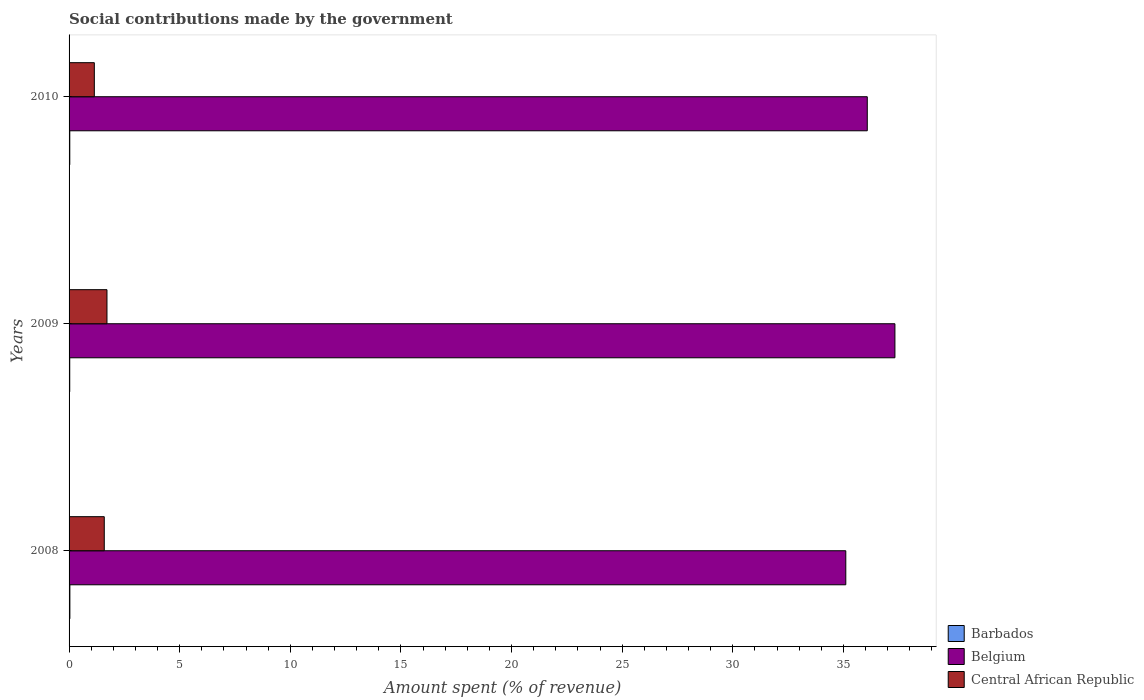How many different coloured bars are there?
Your answer should be very brief. 3. How many groups of bars are there?
Keep it short and to the point. 3. Are the number of bars per tick equal to the number of legend labels?
Your answer should be compact. Yes. Are the number of bars on each tick of the Y-axis equal?
Ensure brevity in your answer.  Yes. How many bars are there on the 1st tick from the bottom?
Offer a very short reply. 3. What is the amount spent (in %) on social contributions in Central African Republic in 2010?
Provide a short and direct response. 1.14. Across all years, what is the maximum amount spent (in %) on social contributions in Barbados?
Make the answer very short. 0.04. Across all years, what is the minimum amount spent (in %) on social contributions in Belgium?
Make the answer very short. 35.11. What is the total amount spent (in %) on social contributions in Barbados in the graph?
Give a very brief answer. 0.1. What is the difference between the amount spent (in %) on social contributions in Central African Republic in 2008 and that in 2009?
Make the answer very short. -0.12. What is the difference between the amount spent (in %) on social contributions in Barbados in 2010 and the amount spent (in %) on social contributions in Belgium in 2009?
Make the answer very short. -37.3. What is the average amount spent (in %) on social contributions in Barbados per year?
Offer a terse response. 0.03. In the year 2009, what is the difference between the amount spent (in %) on social contributions in Belgium and amount spent (in %) on social contributions in Central African Republic?
Your answer should be very brief. 35.62. In how many years, is the amount spent (in %) on social contributions in Barbados greater than 28 %?
Offer a very short reply. 0. What is the ratio of the amount spent (in %) on social contributions in Central African Republic in 2009 to that in 2010?
Provide a succinct answer. 1.5. Is the amount spent (in %) on social contributions in Barbados in 2009 less than that in 2010?
Keep it short and to the point. Yes. What is the difference between the highest and the second highest amount spent (in %) on social contributions in Central African Republic?
Ensure brevity in your answer.  0.12. What is the difference between the highest and the lowest amount spent (in %) on social contributions in Central African Republic?
Your response must be concise. 0.57. In how many years, is the amount spent (in %) on social contributions in Barbados greater than the average amount spent (in %) on social contributions in Barbados taken over all years?
Your answer should be very brief. 1. What does the 3rd bar from the top in 2010 represents?
Provide a short and direct response. Barbados. What does the 3rd bar from the bottom in 2008 represents?
Give a very brief answer. Central African Republic. Are all the bars in the graph horizontal?
Your response must be concise. Yes. Are the values on the major ticks of X-axis written in scientific E-notation?
Offer a terse response. No. Does the graph contain any zero values?
Offer a very short reply. No. Does the graph contain grids?
Provide a short and direct response. No. Where does the legend appear in the graph?
Keep it short and to the point. Bottom right. What is the title of the graph?
Your response must be concise. Social contributions made by the government. Does "Hungary" appear as one of the legend labels in the graph?
Ensure brevity in your answer.  No. What is the label or title of the X-axis?
Give a very brief answer. Amount spent (% of revenue). What is the Amount spent (% of revenue) in Barbados in 2008?
Make the answer very short. 0.04. What is the Amount spent (% of revenue) in Belgium in 2008?
Your answer should be compact. 35.11. What is the Amount spent (% of revenue) in Central African Republic in 2008?
Give a very brief answer. 1.59. What is the Amount spent (% of revenue) of Barbados in 2009?
Your response must be concise. 0.03. What is the Amount spent (% of revenue) of Belgium in 2009?
Keep it short and to the point. 37.33. What is the Amount spent (% of revenue) in Central African Republic in 2009?
Your answer should be compact. 1.71. What is the Amount spent (% of revenue) in Barbados in 2010?
Offer a terse response. 0.03. What is the Amount spent (% of revenue) of Belgium in 2010?
Offer a terse response. 36.08. What is the Amount spent (% of revenue) in Central African Republic in 2010?
Offer a very short reply. 1.14. Across all years, what is the maximum Amount spent (% of revenue) in Barbados?
Provide a short and direct response. 0.04. Across all years, what is the maximum Amount spent (% of revenue) of Belgium?
Offer a very short reply. 37.33. Across all years, what is the maximum Amount spent (% of revenue) of Central African Republic?
Your response must be concise. 1.71. Across all years, what is the minimum Amount spent (% of revenue) of Barbados?
Offer a terse response. 0.03. Across all years, what is the minimum Amount spent (% of revenue) in Belgium?
Your response must be concise. 35.11. Across all years, what is the minimum Amount spent (% of revenue) of Central African Republic?
Make the answer very short. 1.14. What is the total Amount spent (% of revenue) in Barbados in the graph?
Provide a short and direct response. 0.1. What is the total Amount spent (% of revenue) of Belgium in the graph?
Offer a very short reply. 108.52. What is the total Amount spent (% of revenue) in Central African Republic in the graph?
Your response must be concise. 4.45. What is the difference between the Amount spent (% of revenue) in Barbados in 2008 and that in 2009?
Offer a very short reply. 0.01. What is the difference between the Amount spent (% of revenue) of Belgium in 2008 and that in 2009?
Provide a succinct answer. -2.22. What is the difference between the Amount spent (% of revenue) of Central African Republic in 2008 and that in 2009?
Your response must be concise. -0.12. What is the difference between the Amount spent (% of revenue) of Barbados in 2008 and that in 2010?
Provide a short and direct response. 0. What is the difference between the Amount spent (% of revenue) in Belgium in 2008 and that in 2010?
Provide a short and direct response. -0.97. What is the difference between the Amount spent (% of revenue) in Central African Republic in 2008 and that in 2010?
Keep it short and to the point. 0.45. What is the difference between the Amount spent (% of revenue) of Barbados in 2009 and that in 2010?
Make the answer very short. -0. What is the difference between the Amount spent (% of revenue) in Belgium in 2009 and that in 2010?
Offer a terse response. 1.25. What is the difference between the Amount spent (% of revenue) in Central African Republic in 2009 and that in 2010?
Make the answer very short. 0.57. What is the difference between the Amount spent (% of revenue) in Barbados in 2008 and the Amount spent (% of revenue) in Belgium in 2009?
Offer a very short reply. -37.29. What is the difference between the Amount spent (% of revenue) in Barbados in 2008 and the Amount spent (% of revenue) in Central African Republic in 2009?
Offer a terse response. -1.68. What is the difference between the Amount spent (% of revenue) of Belgium in 2008 and the Amount spent (% of revenue) of Central African Republic in 2009?
Provide a succinct answer. 33.4. What is the difference between the Amount spent (% of revenue) in Barbados in 2008 and the Amount spent (% of revenue) in Belgium in 2010?
Give a very brief answer. -36.04. What is the difference between the Amount spent (% of revenue) of Barbados in 2008 and the Amount spent (% of revenue) of Central African Republic in 2010?
Provide a short and direct response. -1.11. What is the difference between the Amount spent (% of revenue) of Belgium in 2008 and the Amount spent (% of revenue) of Central African Republic in 2010?
Your answer should be very brief. 33.97. What is the difference between the Amount spent (% of revenue) of Barbados in 2009 and the Amount spent (% of revenue) of Belgium in 2010?
Provide a succinct answer. -36.05. What is the difference between the Amount spent (% of revenue) of Barbados in 2009 and the Amount spent (% of revenue) of Central African Republic in 2010?
Your answer should be compact. -1.11. What is the difference between the Amount spent (% of revenue) in Belgium in 2009 and the Amount spent (% of revenue) in Central African Republic in 2010?
Your response must be concise. 36.19. What is the average Amount spent (% of revenue) of Barbados per year?
Provide a succinct answer. 0.03. What is the average Amount spent (% of revenue) of Belgium per year?
Offer a very short reply. 36.17. What is the average Amount spent (% of revenue) in Central African Republic per year?
Make the answer very short. 1.48. In the year 2008, what is the difference between the Amount spent (% of revenue) of Barbados and Amount spent (% of revenue) of Belgium?
Make the answer very short. -35.07. In the year 2008, what is the difference between the Amount spent (% of revenue) in Barbados and Amount spent (% of revenue) in Central African Republic?
Your answer should be very brief. -1.55. In the year 2008, what is the difference between the Amount spent (% of revenue) of Belgium and Amount spent (% of revenue) of Central African Republic?
Offer a terse response. 33.52. In the year 2009, what is the difference between the Amount spent (% of revenue) of Barbados and Amount spent (% of revenue) of Belgium?
Ensure brevity in your answer.  -37.3. In the year 2009, what is the difference between the Amount spent (% of revenue) of Barbados and Amount spent (% of revenue) of Central African Republic?
Your answer should be compact. -1.68. In the year 2009, what is the difference between the Amount spent (% of revenue) of Belgium and Amount spent (% of revenue) of Central African Republic?
Provide a short and direct response. 35.62. In the year 2010, what is the difference between the Amount spent (% of revenue) in Barbados and Amount spent (% of revenue) in Belgium?
Offer a very short reply. -36.05. In the year 2010, what is the difference between the Amount spent (% of revenue) in Barbados and Amount spent (% of revenue) in Central African Republic?
Make the answer very short. -1.11. In the year 2010, what is the difference between the Amount spent (% of revenue) of Belgium and Amount spent (% of revenue) of Central African Republic?
Your answer should be compact. 34.94. What is the ratio of the Amount spent (% of revenue) in Barbados in 2008 to that in 2009?
Provide a short and direct response. 1.21. What is the ratio of the Amount spent (% of revenue) in Belgium in 2008 to that in 2009?
Your response must be concise. 0.94. What is the ratio of the Amount spent (% of revenue) of Central African Republic in 2008 to that in 2009?
Provide a short and direct response. 0.93. What is the ratio of the Amount spent (% of revenue) in Barbados in 2008 to that in 2010?
Offer a terse response. 1.12. What is the ratio of the Amount spent (% of revenue) in Belgium in 2008 to that in 2010?
Make the answer very short. 0.97. What is the ratio of the Amount spent (% of revenue) in Central African Republic in 2008 to that in 2010?
Keep it short and to the point. 1.39. What is the ratio of the Amount spent (% of revenue) in Barbados in 2009 to that in 2010?
Your response must be concise. 0.92. What is the ratio of the Amount spent (% of revenue) of Belgium in 2009 to that in 2010?
Your response must be concise. 1.03. What is the ratio of the Amount spent (% of revenue) in Central African Republic in 2009 to that in 2010?
Give a very brief answer. 1.5. What is the difference between the highest and the second highest Amount spent (% of revenue) in Barbados?
Your answer should be very brief. 0. What is the difference between the highest and the second highest Amount spent (% of revenue) in Belgium?
Provide a short and direct response. 1.25. What is the difference between the highest and the second highest Amount spent (% of revenue) in Central African Republic?
Provide a succinct answer. 0.12. What is the difference between the highest and the lowest Amount spent (% of revenue) in Barbados?
Your answer should be compact. 0.01. What is the difference between the highest and the lowest Amount spent (% of revenue) of Belgium?
Your answer should be very brief. 2.22. What is the difference between the highest and the lowest Amount spent (% of revenue) of Central African Republic?
Ensure brevity in your answer.  0.57. 